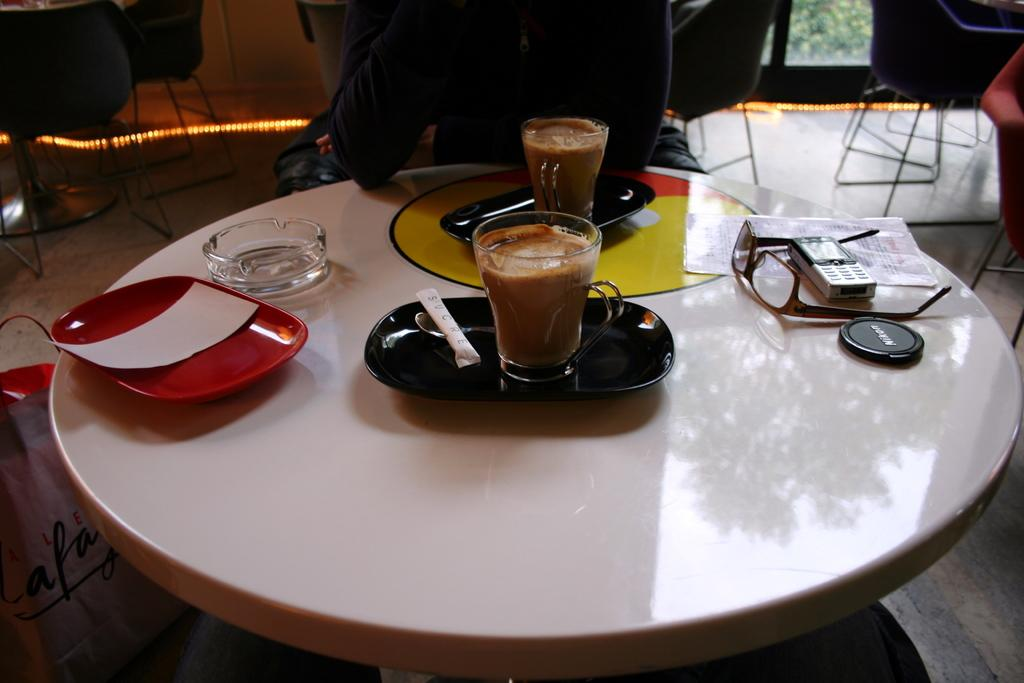What piece of furniture is present in the image? There is a table in the image. What items can be seen on the table? There are cups, plates, a bowl, spectacles, and a mobile on the table. Are there any seating options visible in the image? Yes, there are chairs in the image. What part of the room can be seen in the image? The floor is visible in the image. How does the sofa contribute to the pollution in the image? There is no sofa present in the image, so it cannot contribute to any pollution. 